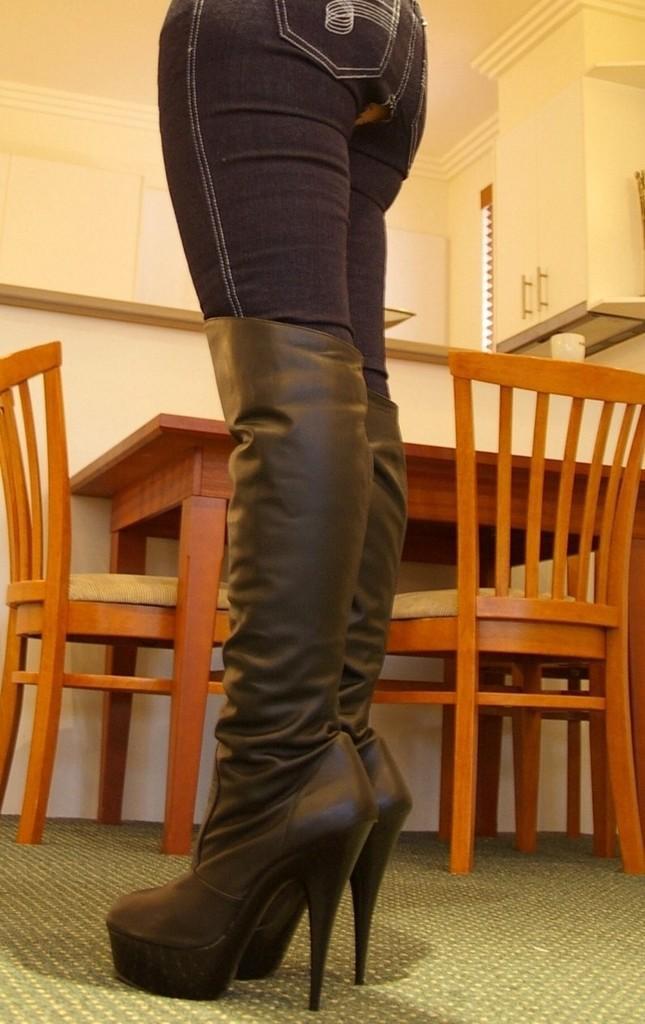Please provide a concise description of this image. Image is clicked in a room. There is a dining table in the middle, it has one table and 2 chairs, one chair is on the left side and other chair on the right side. There are boards on the right side. There is a woman standing in the middle. She wore shoes and Black jeans. 